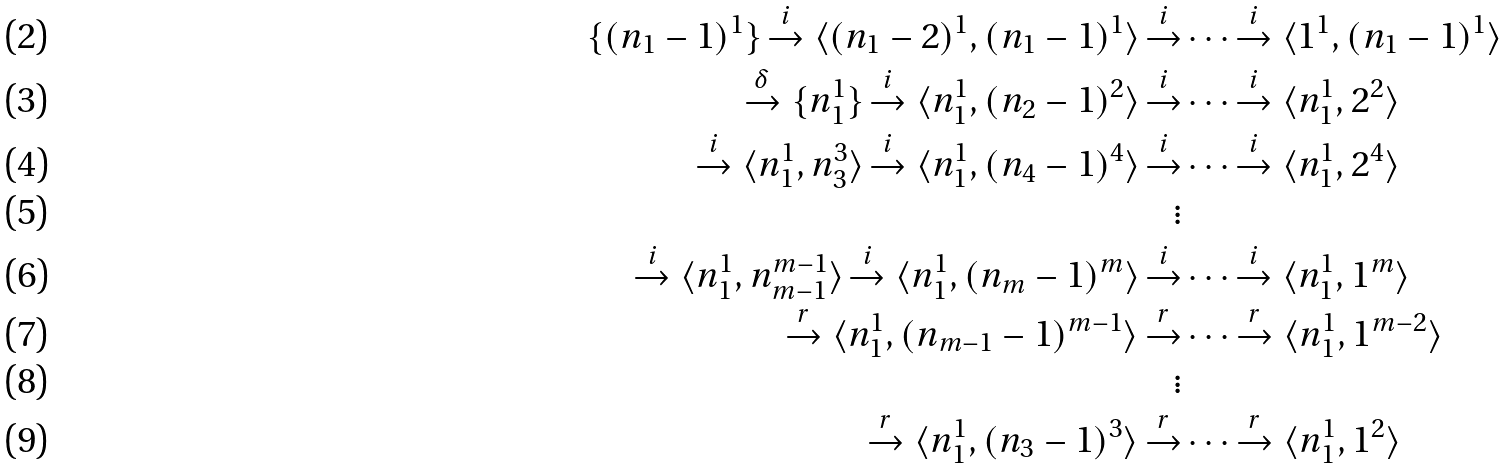<formula> <loc_0><loc_0><loc_500><loc_500>\{ ( n _ { 1 } - 1 ) ^ { 1 } \} \xrightarrow { i } \langle ( n _ { 1 } - 2 ) ^ { 1 } , ( n _ { 1 } - 1 ) ^ { 1 } \rangle \xrightarrow { i } & \cdots \xrightarrow { i } \langle 1 ^ { 1 } , ( n _ { 1 } - 1 ) ^ { 1 } \rangle \\ \xrightarrow { \delta } \{ n _ { 1 } ^ { 1 } \} \xrightarrow { i } \langle n _ { 1 } ^ { 1 } , ( n _ { 2 } - 1 ) ^ { 2 } \rangle \xrightarrow { i } & \cdots \xrightarrow { i } \langle n _ { 1 } ^ { 1 } , 2 ^ { 2 } \rangle \\ \xrightarrow { i } \langle n _ { 1 } ^ { 1 } , n _ { 3 } ^ { 3 } \rangle \xrightarrow { i } \langle n _ { 1 } ^ { 1 } , ( n _ { 4 } - 1 ) ^ { 4 } \rangle \xrightarrow { i } & \cdots \xrightarrow { i } \langle n _ { 1 } ^ { 1 } , 2 ^ { 4 } \rangle \\ \vdots \\ \xrightarrow { i } \langle n _ { 1 } ^ { 1 } , n _ { m - 1 } ^ { m - 1 } \rangle \xrightarrow { i } \langle n _ { 1 } ^ { 1 } , ( n _ { m } - 1 ) ^ { m } \rangle \xrightarrow { i } & \cdots \xrightarrow { i } \langle n _ { 1 } ^ { 1 } , 1 ^ { m } \rangle \\ \xrightarrow { r } \langle n _ { 1 } ^ { 1 } , ( n _ { m - 1 } - 1 ) ^ { m - 1 } \rangle \xrightarrow { r } & \cdots \xrightarrow { r } \langle n _ { 1 } ^ { 1 } , 1 ^ { m - 2 } \rangle \\ \vdots \\ \xrightarrow { r } \langle n _ { 1 } ^ { 1 } , ( n _ { 3 } - 1 ) ^ { 3 } \rangle \xrightarrow { r } & \cdots \xrightarrow { r } \langle n _ { 1 } ^ { 1 } , 1 ^ { 2 } \rangle</formula> 